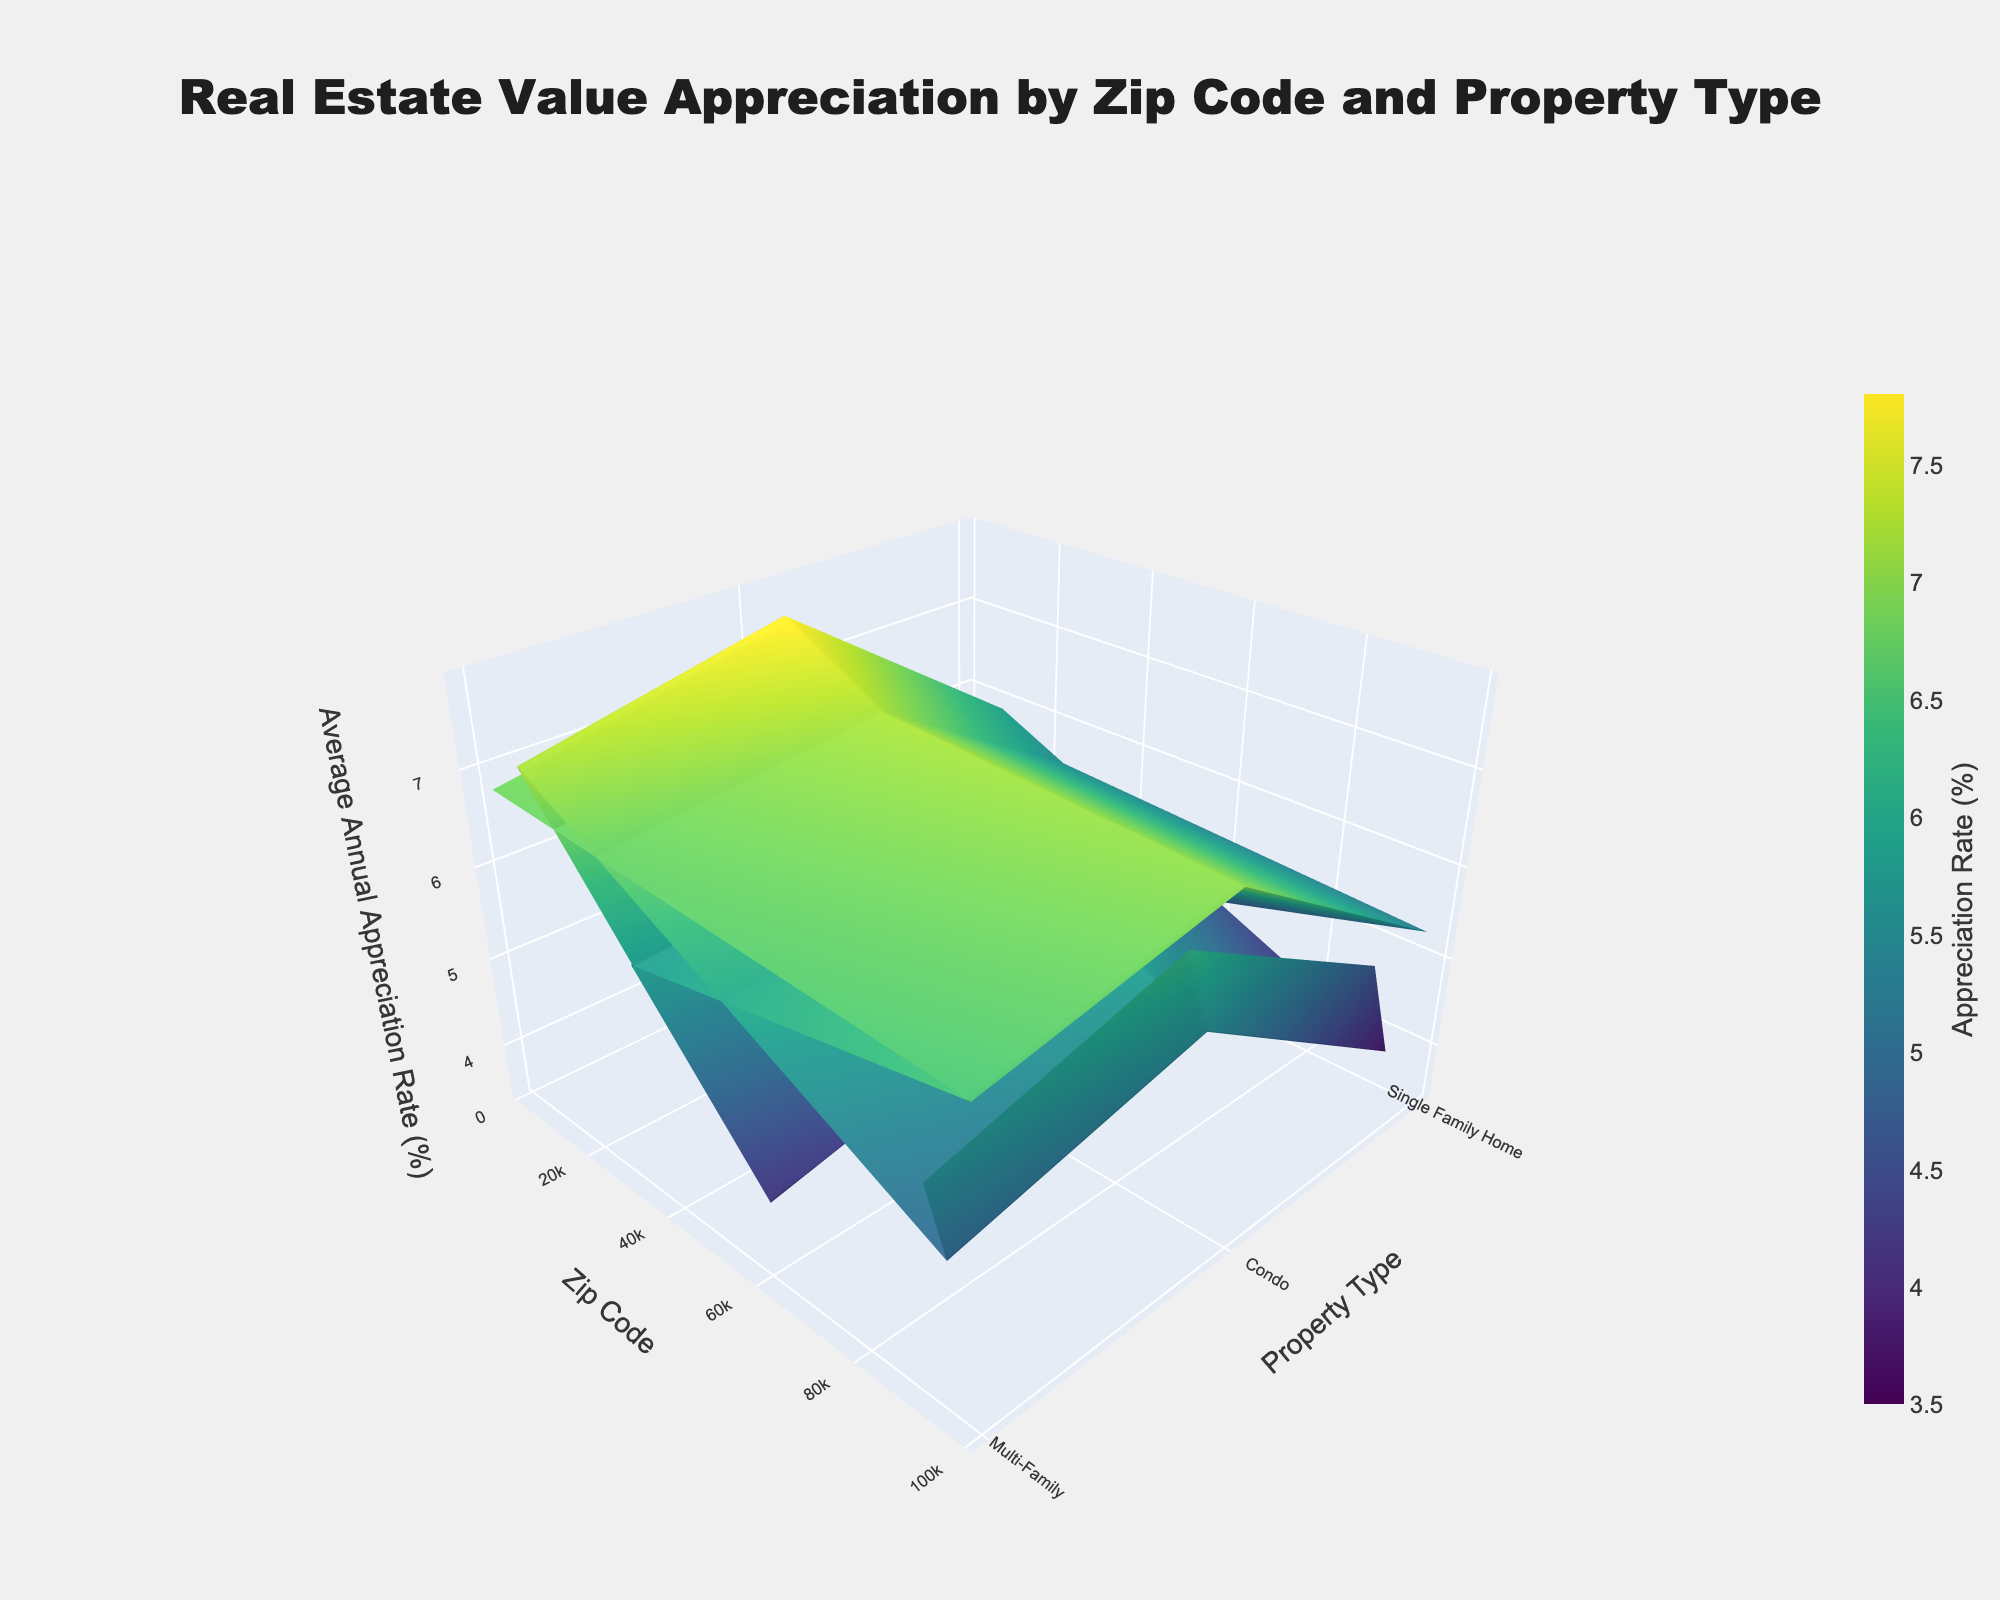What's the title of the figure? The title is displayed prominently at the top of the plot, often in a larger font size and bold text.
Answer: Real Estate Value Appreciation by Zip Code and Property Type What do the color variations represent in the plot? The color variations are shown on the color bar next to the plot, indicating they represent different appreciation rates with a gradient color scheme.
Answer: Appreciation Rate (%) Which property type in zip code 94123 appreciated the most? Look at the y-axis for zip code 94123 and follow the color intensity on the surface plot for different property types. The most intense color indicates the highest appreciation rate.
Answer: Multi-Family How does the appreciation rate of Single Family Homes in 10022 compare to Condos in the same zip code? Identify the coordinates for Single Family Homes and Condos in zip code 10022 and compare the heights/values in the 3D plot.
Answer: Higher What is the overall trend in appreciation rates by property type in zip code 60611? Look at the segments corresponding to zip code 60611 and observe the trends for different property types by following the surface heights/colors.
Answer: Decreasing from Single Family Home to Condo Which zip code has the highest average annual appreciation rate for Single Family Homes? Examine the Single Family Home axis in the plot and look for the highest point along the different zip code segments.
Answer: 33139 Compare the average annual appreciation rates for Condos in zip codes 90210 and 98101. Which one is higher? Locate the points for Condos in both zip codes and compare their heights/colors directly.
Answer: 98101 What are the axes titles in the figure? The axes titles describe the dimensions represented in the 3D plot, typically appearing next to each axis in a larger font compared to the tick labels.
Answer: Property Type, Zip Code, Average Annual Appreciation Rate (%) How much greater is the appreciation rate for Multi-Family properties in 10022 compared to Condos in the same zip code? Subtract the appreciation rate of Condos from that of Multi-Family properties in 10022, using the heights/values from the plot.
Answer: 1.7% What insight can you draw about property appreciation trends in zip code 33139? Analyze the segments for zip code 33139 and note which property type shows the highest appreciation, indicating overall property trends in this area.
Answer: Multi-Family properties have the highest appreciation rate 